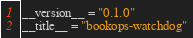Convert code to text. <code><loc_0><loc_0><loc_500><loc_500><_Python_>__version__ = "0.1.0"
__title__ = "bookops-watchdog"
</code> 